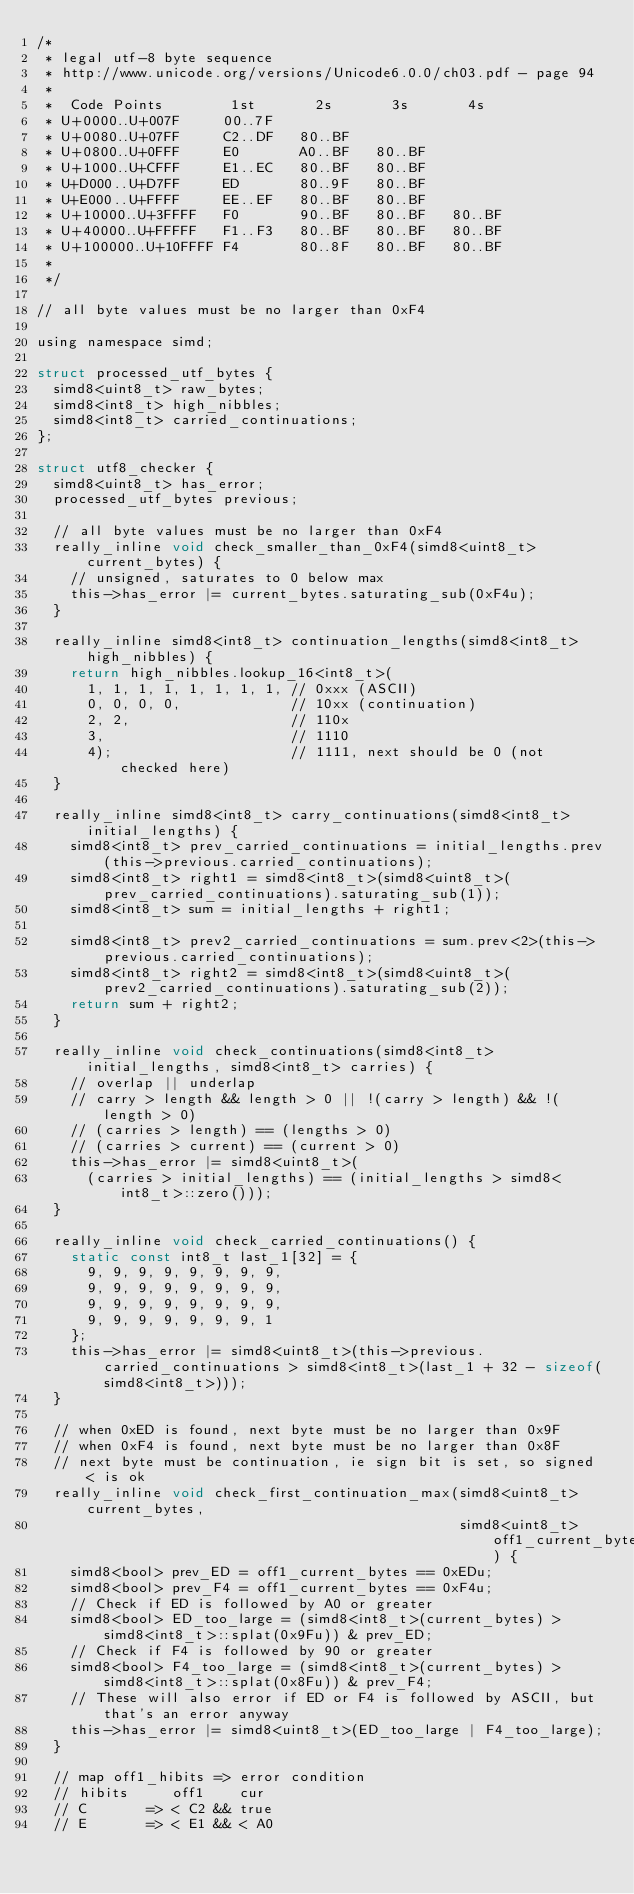Convert code to text. <code><loc_0><loc_0><loc_500><loc_500><_C_>/*
 * legal utf-8 byte sequence
 * http://www.unicode.org/versions/Unicode6.0.0/ch03.pdf - page 94
 *
 *  Code Points        1st       2s       3s       4s
 * U+0000..U+007F     00..7F
 * U+0080..U+07FF     C2..DF   80..BF
 * U+0800..U+0FFF     E0       A0..BF   80..BF
 * U+1000..U+CFFF     E1..EC   80..BF   80..BF
 * U+D000..U+D7FF     ED       80..9F   80..BF
 * U+E000..U+FFFF     EE..EF   80..BF   80..BF
 * U+10000..U+3FFFF   F0       90..BF   80..BF   80..BF
 * U+40000..U+FFFFF   F1..F3   80..BF   80..BF   80..BF
 * U+100000..U+10FFFF F4       80..8F   80..BF   80..BF
 *
 */

// all byte values must be no larger than 0xF4

using namespace simd;

struct processed_utf_bytes {
  simd8<uint8_t> raw_bytes;
  simd8<int8_t> high_nibbles;
  simd8<int8_t> carried_continuations;
};

struct utf8_checker {
  simd8<uint8_t> has_error;
  processed_utf_bytes previous;

  // all byte values must be no larger than 0xF4
  really_inline void check_smaller_than_0xF4(simd8<uint8_t> current_bytes) {
    // unsigned, saturates to 0 below max
    this->has_error |= current_bytes.saturating_sub(0xF4u);
  }

  really_inline simd8<int8_t> continuation_lengths(simd8<int8_t> high_nibbles) {
    return high_nibbles.lookup_16<int8_t>(
      1, 1, 1, 1, 1, 1, 1, 1, // 0xxx (ASCII)
      0, 0, 0, 0,             // 10xx (continuation)
      2, 2,                   // 110x
      3,                      // 1110
      4);                     // 1111, next should be 0 (not checked here)
  }

  really_inline simd8<int8_t> carry_continuations(simd8<int8_t> initial_lengths) {
    simd8<int8_t> prev_carried_continuations = initial_lengths.prev(this->previous.carried_continuations);
    simd8<int8_t> right1 = simd8<int8_t>(simd8<uint8_t>(prev_carried_continuations).saturating_sub(1));
    simd8<int8_t> sum = initial_lengths + right1;

    simd8<int8_t> prev2_carried_continuations = sum.prev<2>(this->previous.carried_continuations);
    simd8<int8_t> right2 = simd8<int8_t>(simd8<uint8_t>(prev2_carried_continuations).saturating_sub(2));
    return sum + right2;
  }

  really_inline void check_continuations(simd8<int8_t> initial_lengths, simd8<int8_t> carries) {
    // overlap || underlap
    // carry > length && length > 0 || !(carry > length) && !(length > 0)
    // (carries > length) == (lengths > 0)
    // (carries > current) == (current > 0)
    this->has_error |= simd8<uint8_t>(
      (carries > initial_lengths) == (initial_lengths > simd8<int8_t>::zero()));
  }

  really_inline void check_carried_continuations() {
    static const int8_t last_1[32] = {
      9, 9, 9, 9, 9, 9, 9, 9,
      9, 9, 9, 9, 9, 9, 9, 9,
      9, 9, 9, 9, 9, 9, 9, 9,
      9, 9, 9, 9, 9, 9, 9, 1
    };
    this->has_error |= simd8<uint8_t>(this->previous.carried_continuations > simd8<int8_t>(last_1 + 32 - sizeof(simd8<int8_t>)));
  }

  // when 0xED is found, next byte must be no larger than 0x9F
  // when 0xF4 is found, next byte must be no larger than 0x8F
  // next byte must be continuation, ie sign bit is set, so signed < is ok
  really_inline void check_first_continuation_max(simd8<uint8_t> current_bytes,
                                                  simd8<uint8_t> off1_current_bytes) {
    simd8<bool> prev_ED = off1_current_bytes == 0xEDu;
    simd8<bool> prev_F4 = off1_current_bytes == 0xF4u;
    // Check if ED is followed by A0 or greater
    simd8<bool> ED_too_large = (simd8<int8_t>(current_bytes) > simd8<int8_t>::splat(0x9Fu)) & prev_ED;
    // Check if F4 is followed by 90 or greater
    simd8<bool> F4_too_large = (simd8<int8_t>(current_bytes) > simd8<int8_t>::splat(0x8Fu)) & prev_F4;
    // These will also error if ED or F4 is followed by ASCII, but that's an error anyway
    this->has_error |= simd8<uint8_t>(ED_too_large | F4_too_large);
  }

  // map off1_hibits => error condition
  // hibits     off1    cur
  // C       => < C2 && true
  // E       => < E1 && < A0</code> 